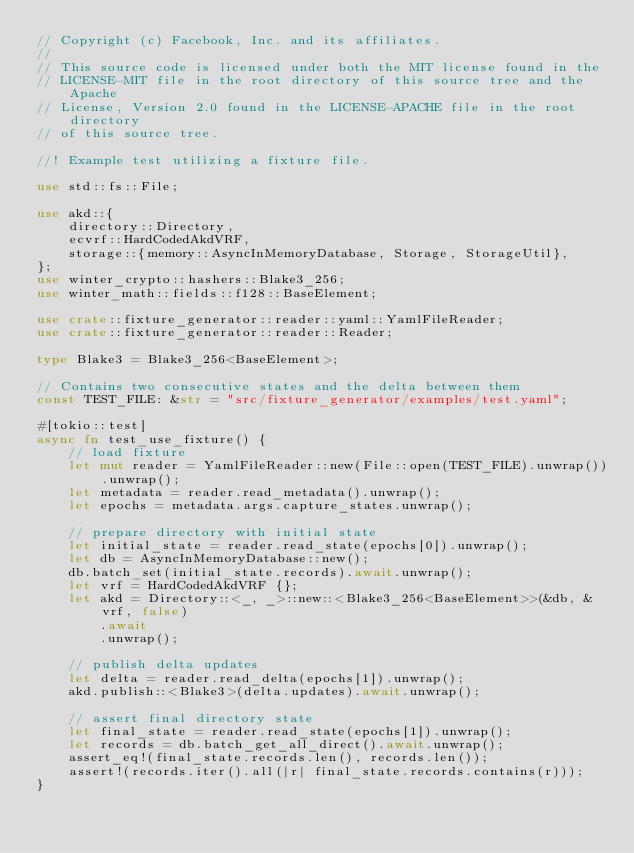<code> <loc_0><loc_0><loc_500><loc_500><_Rust_>// Copyright (c) Facebook, Inc. and its affiliates.
//
// This source code is licensed under both the MIT license found in the
// LICENSE-MIT file in the root directory of this source tree and the Apache
// License, Version 2.0 found in the LICENSE-APACHE file in the root directory
// of this source tree.

//! Example test utilizing a fixture file.

use std::fs::File;

use akd::{
    directory::Directory,
    ecvrf::HardCodedAkdVRF,
    storage::{memory::AsyncInMemoryDatabase, Storage, StorageUtil},
};
use winter_crypto::hashers::Blake3_256;
use winter_math::fields::f128::BaseElement;

use crate::fixture_generator::reader::yaml::YamlFileReader;
use crate::fixture_generator::reader::Reader;

type Blake3 = Blake3_256<BaseElement>;

// Contains two consecutive states and the delta between them
const TEST_FILE: &str = "src/fixture_generator/examples/test.yaml";

#[tokio::test]
async fn test_use_fixture() {
    // load fixture
    let mut reader = YamlFileReader::new(File::open(TEST_FILE).unwrap()).unwrap();
    let metadata = reader.read_metadata().unwrap();
    let epochs = metadata.args.capture_states.unwrap();

    // prepare directory with initial state
    let initial_state = reader.read_state(epochs[0]).unwrap();
    let db = AsyncInMemoryDatabase::new();
    db.batch_set(initial_state.records).await.unwrap();
    let vrf = HardCodedAkdVRF {};
    let akd = Directory::<_, _>::new::<Blake3_256<BaseElement>>(&db, &vrf, false)
        .await
        .unwrap();

    // publish delta updates
    let delta = reader.read_delta(epochs[1]).unwrap();
    akd.publish::<Blake3>(delta.updates).await.unwrap();

    // assert final directory state
    let final_state = reader.read_state(epochs[1]).unwrap();
    let records = db.batch_get_all_direct().await.unwrap();
    assert_eq!(final_state.records.len(), records.len());
    assert!(records.iter().all(|r| final_state.records.contains(r)));
}
</code> 